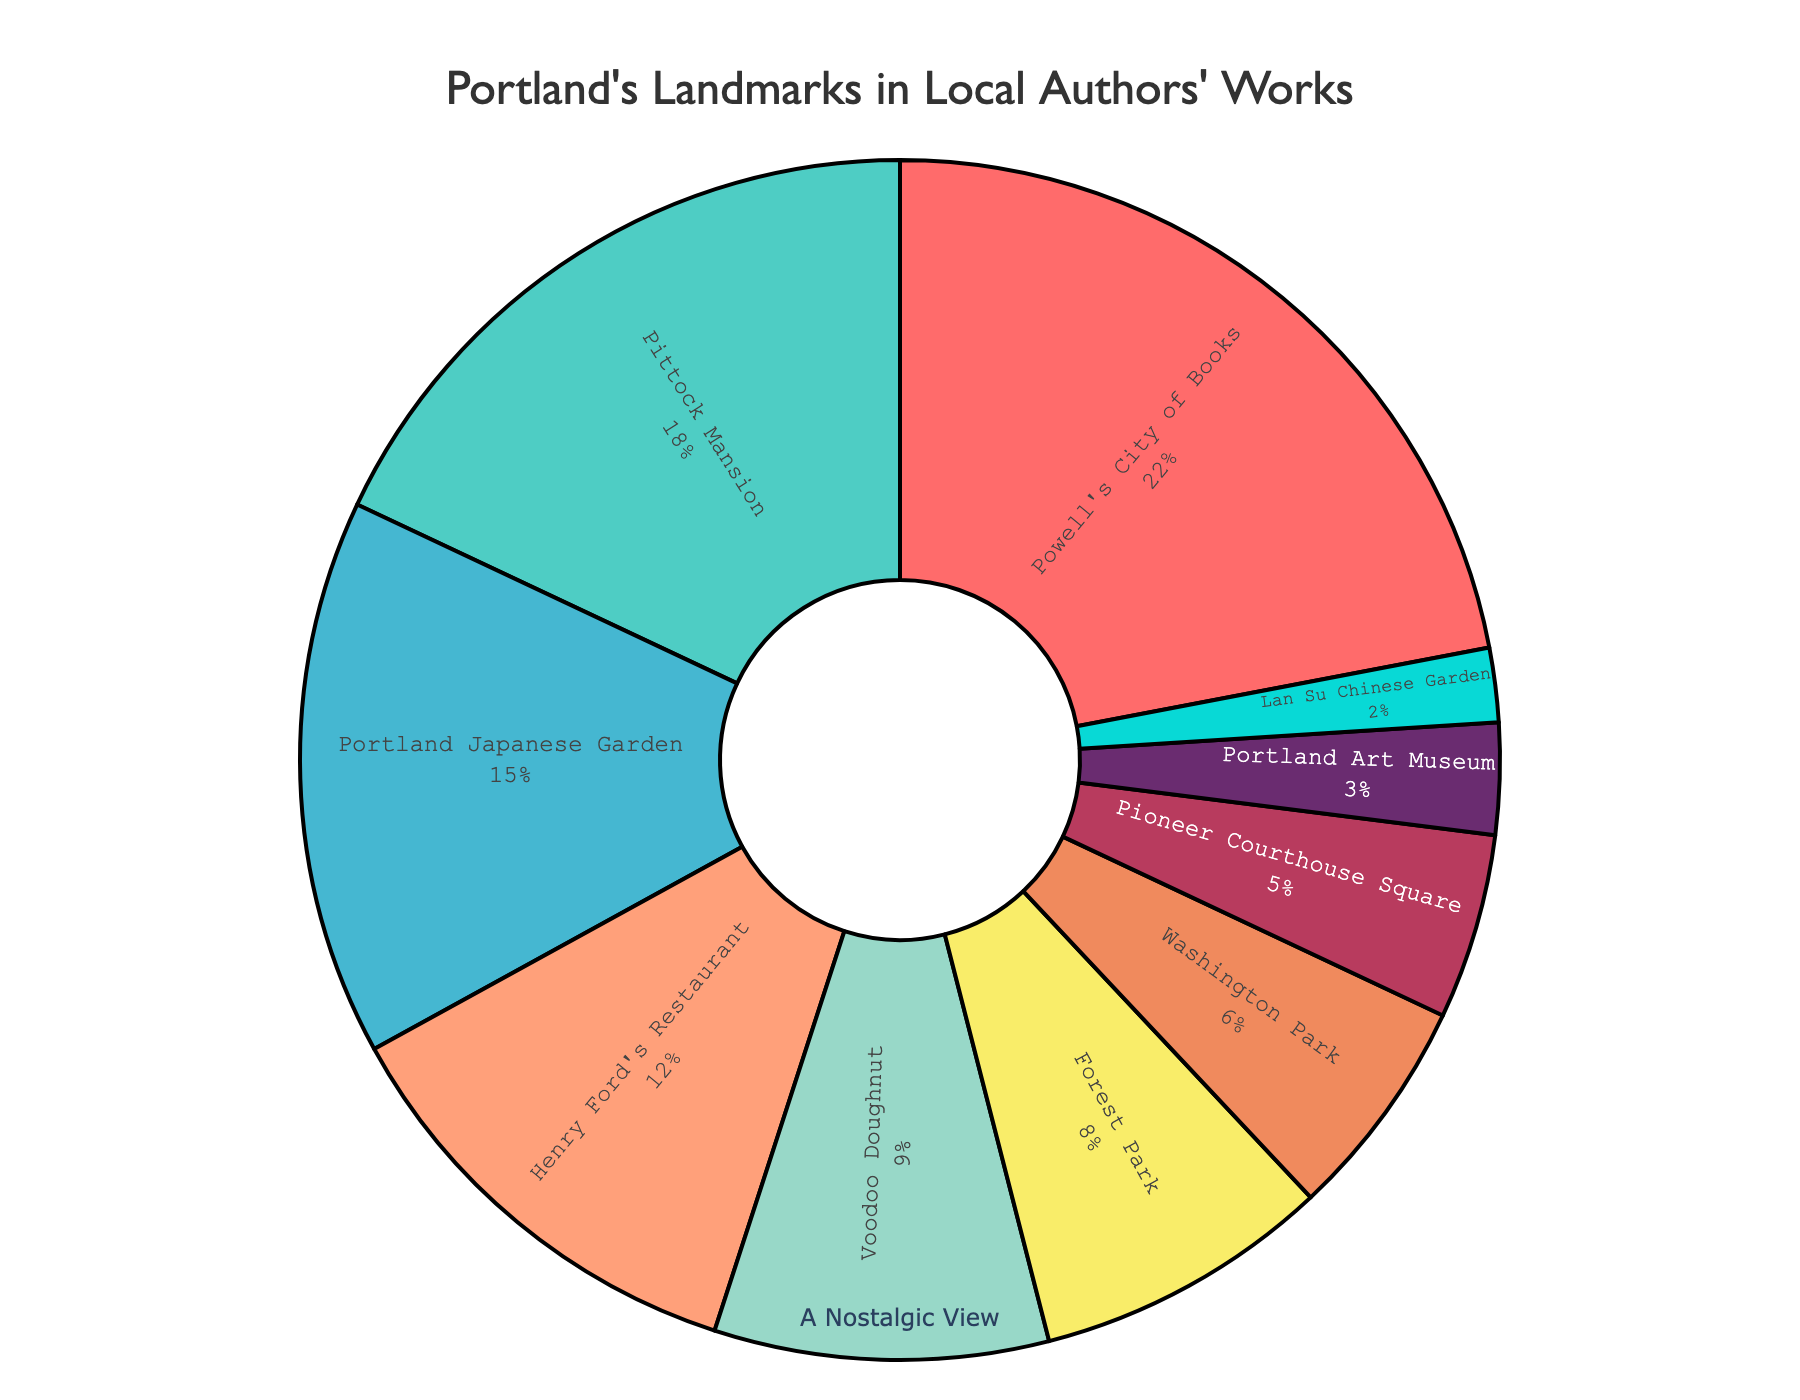What's the most featured landmark in local authors' works? By looking at the pie chart, we can see that Powell's City of Books has the largest section, which indicates it has the highest percentage.
Answer: Powell's City of Books How much more percentage does Powell's City of Books have compared to Henry Ford's Restaurant? The percentage of Powell's City of Books is 22%, and Henry Ford's Restaurant is 12%. The difference is calculated as 22% - 12%.
Answer: 10% Which has a smaller representation, Voodoo Doughnut or Forest Park? By comparing the size of the pie sections and the percentages indicated, Voodoo Doughnut has 9% while Forest Park has 8%. Thus, Forest Park has a smaller representation.
Answer: Forest Park Combine the percentages of Pittock Mansion and Portland Art Museum. What is the total? Pittock Mansion has 18% and Portland Art Museum has 3%. Adding them together gives 18% + 3% = 21%.
Answer: 21% What percentage of works mention either Washington Park or Lan Su Chinese Garden? Washington Park has 6%, and Lan Su Chinese Garden has 2%. Adding them together gives 6% + 2% = 8%.
Answer: 8% Does Portland Japanese Garden have a higher percentage than Henry Ford's Restaurant? Comparing the two, Portland Japanese Garden has 15% while Henry Ford's Restaurant has 12%. Portland Japanese Garden has a higher percentage.
Answer: Yes Out of all listed landmarks, which one has the least representation in local authors' works? By examining the pie chart for the smallest section, Lan Su Chinese Garden has the lowest percentage at 2%.
Answer: Lan Su Chinese Garden If we combine the percentages of all landmarks with less than 10% representation, what's the total percentage? Summing up the percentages of Voodoo Doughnut (9%), Forest Park (8%), Washington Park (6%), Pioneer Courthouse Square (5%), Portland Art Museum (3%), and Lan Su Chinese Garden (2%): 9% + 8% + 6% + 5% + 3% + 2% = 33%.
Answer: 33% How does the percentage of Pittock Mansion compare with that of Portland Japanese Garden? Pittock Mansion has 18%, and Portland Japanese Garden has 15%. Comparing them, Pittock Mansion has a higher percentage.
Answer: Pittock Mansion has a higher percentage What combined percentage is represented by Powell's City of Books, Pittock Mansion, and Portland Japanese Garden? Adding the three percentages: Powell's City of Books (22%), Pittock Mansion (18%), and Portland Japanese Garden (15%): 22% + 18% + 15% = 55%.
Answer: 55% 